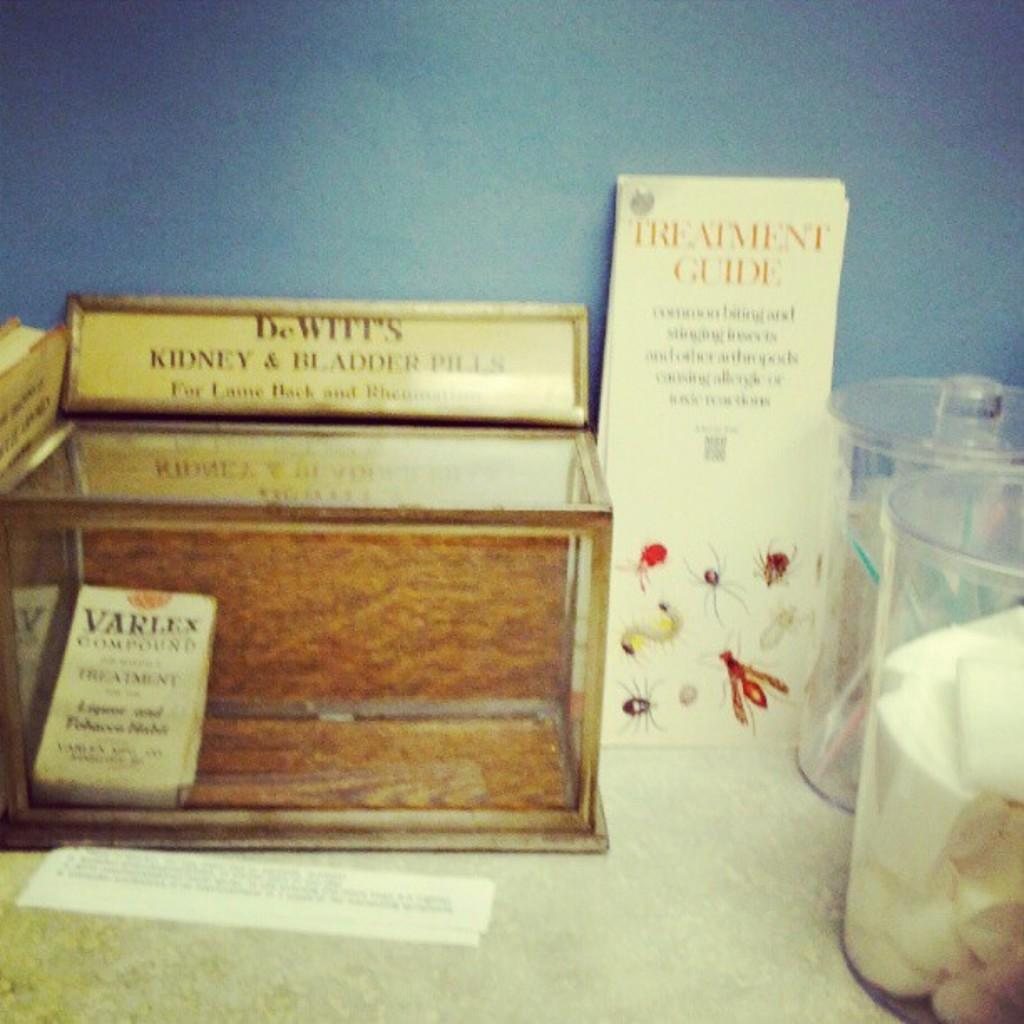<image>
Offer a succinct explanation of the picture presented. A wooden and glass box sits on a counter with a name plate for DeWitt's Kidney and Bladder Pills sitting on top of the box. 